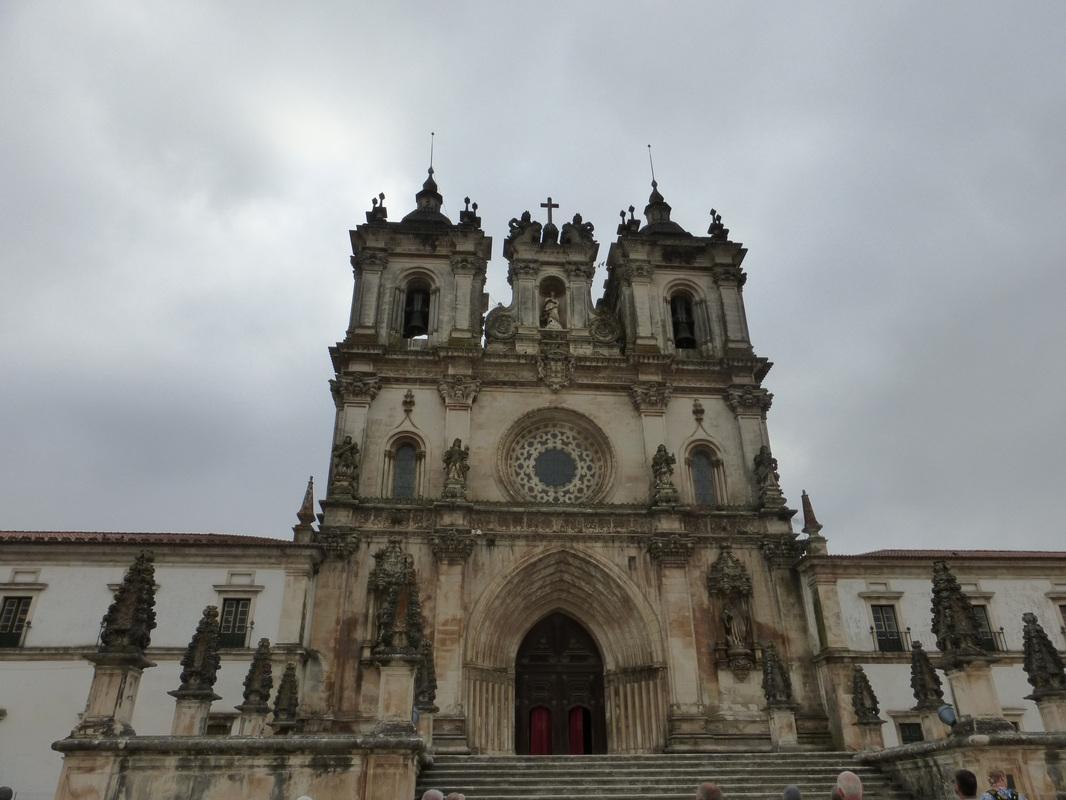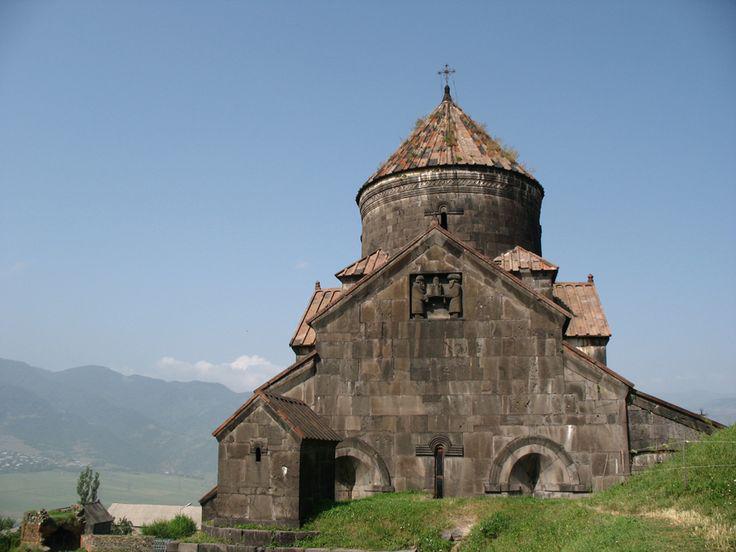The first image is the image on the left, the second image is the image on the right. For the images displayed, is the sentence "An image shows a mottled gray building with a cone-shaped roof that has something growing on it." factually correct? Answer yes or no. Yes. 